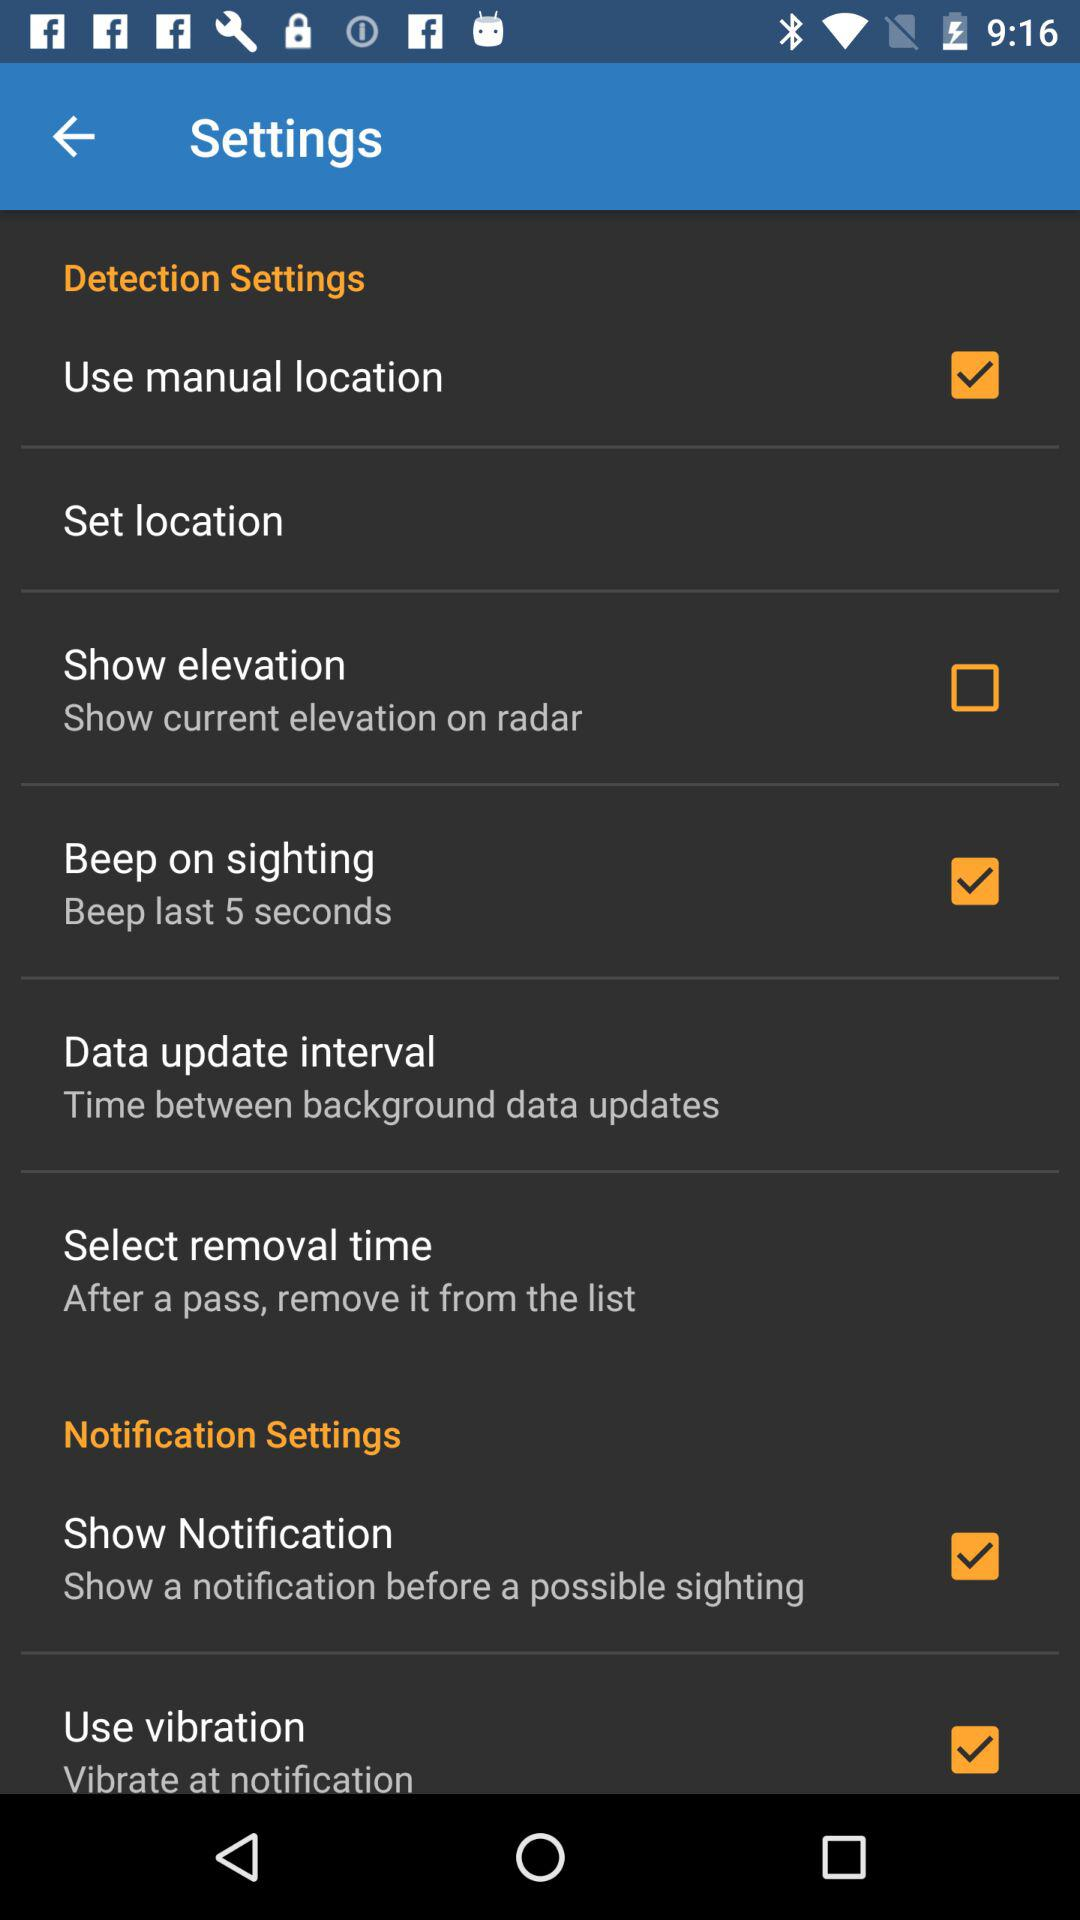What is the status of "Use vibration"? The status is "on". 